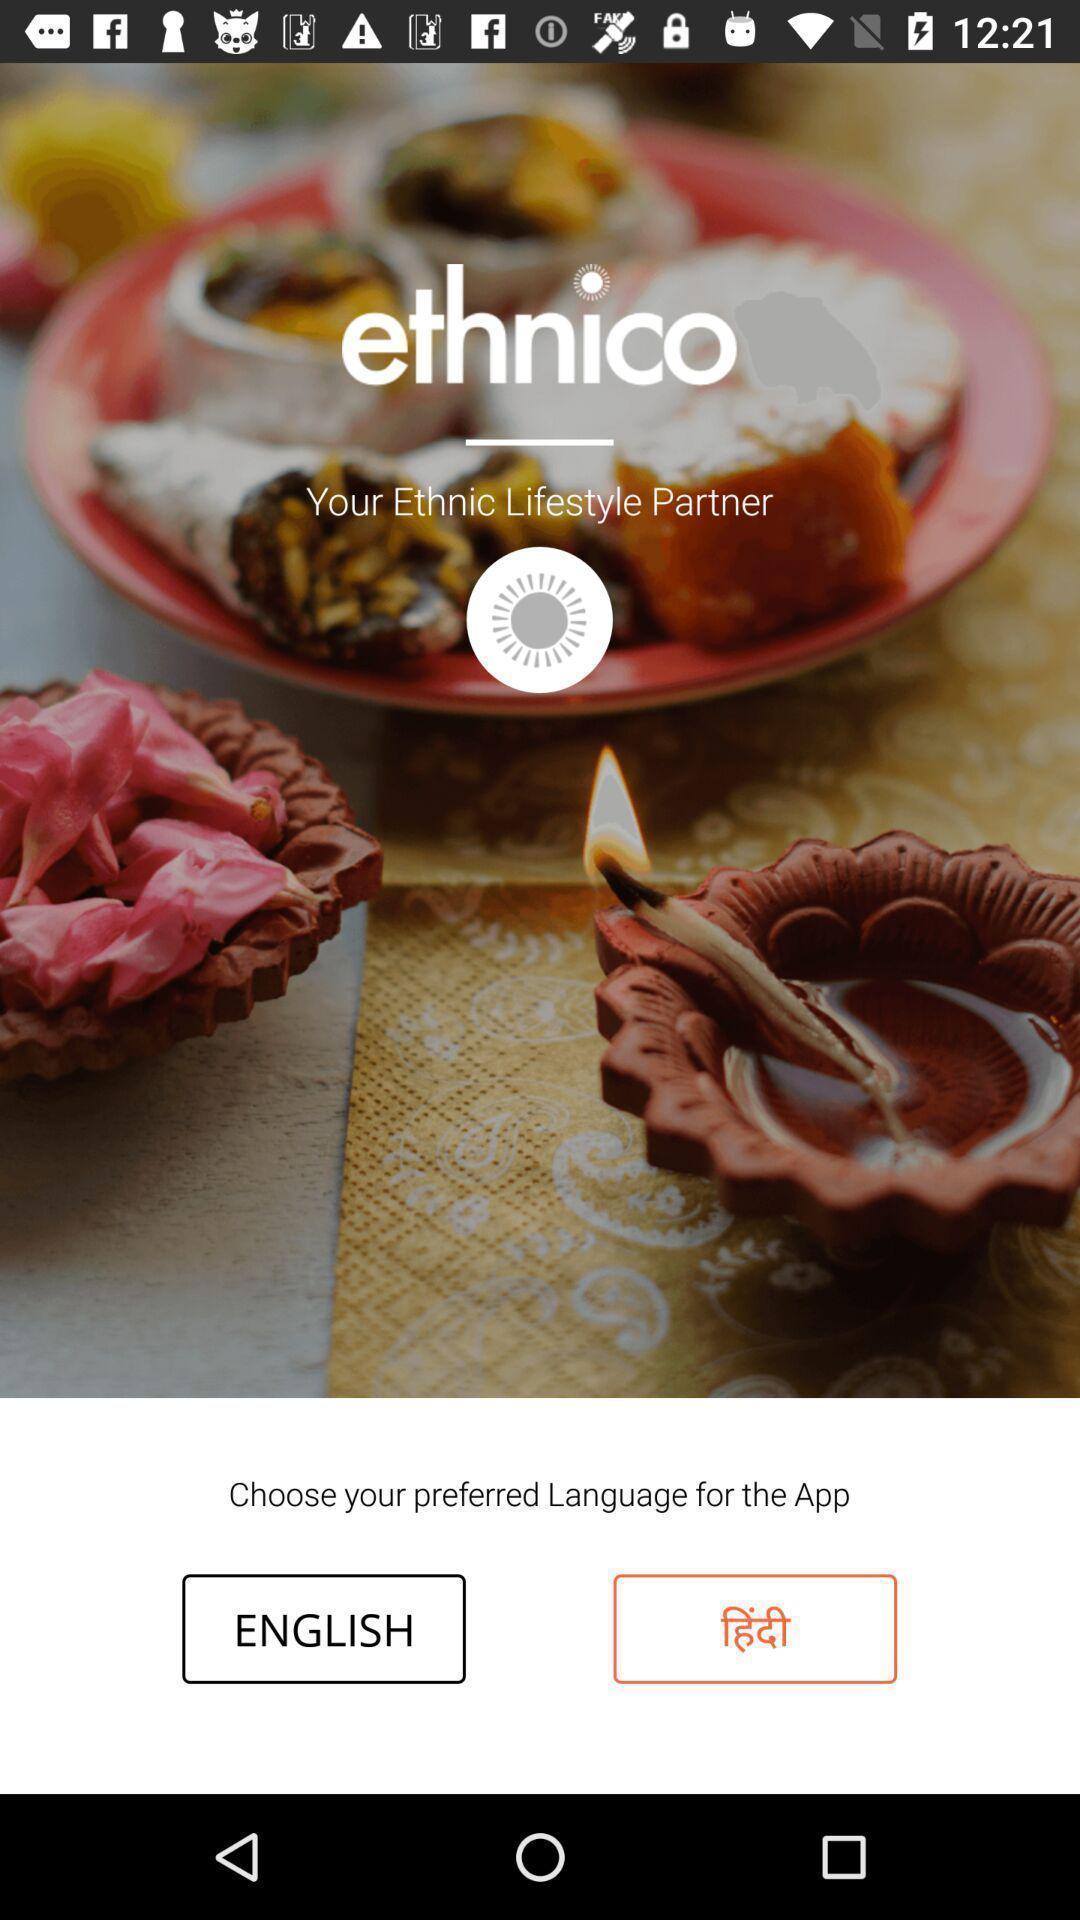Please provide a description for this image. Page to confirm language in a lifestyle app. 